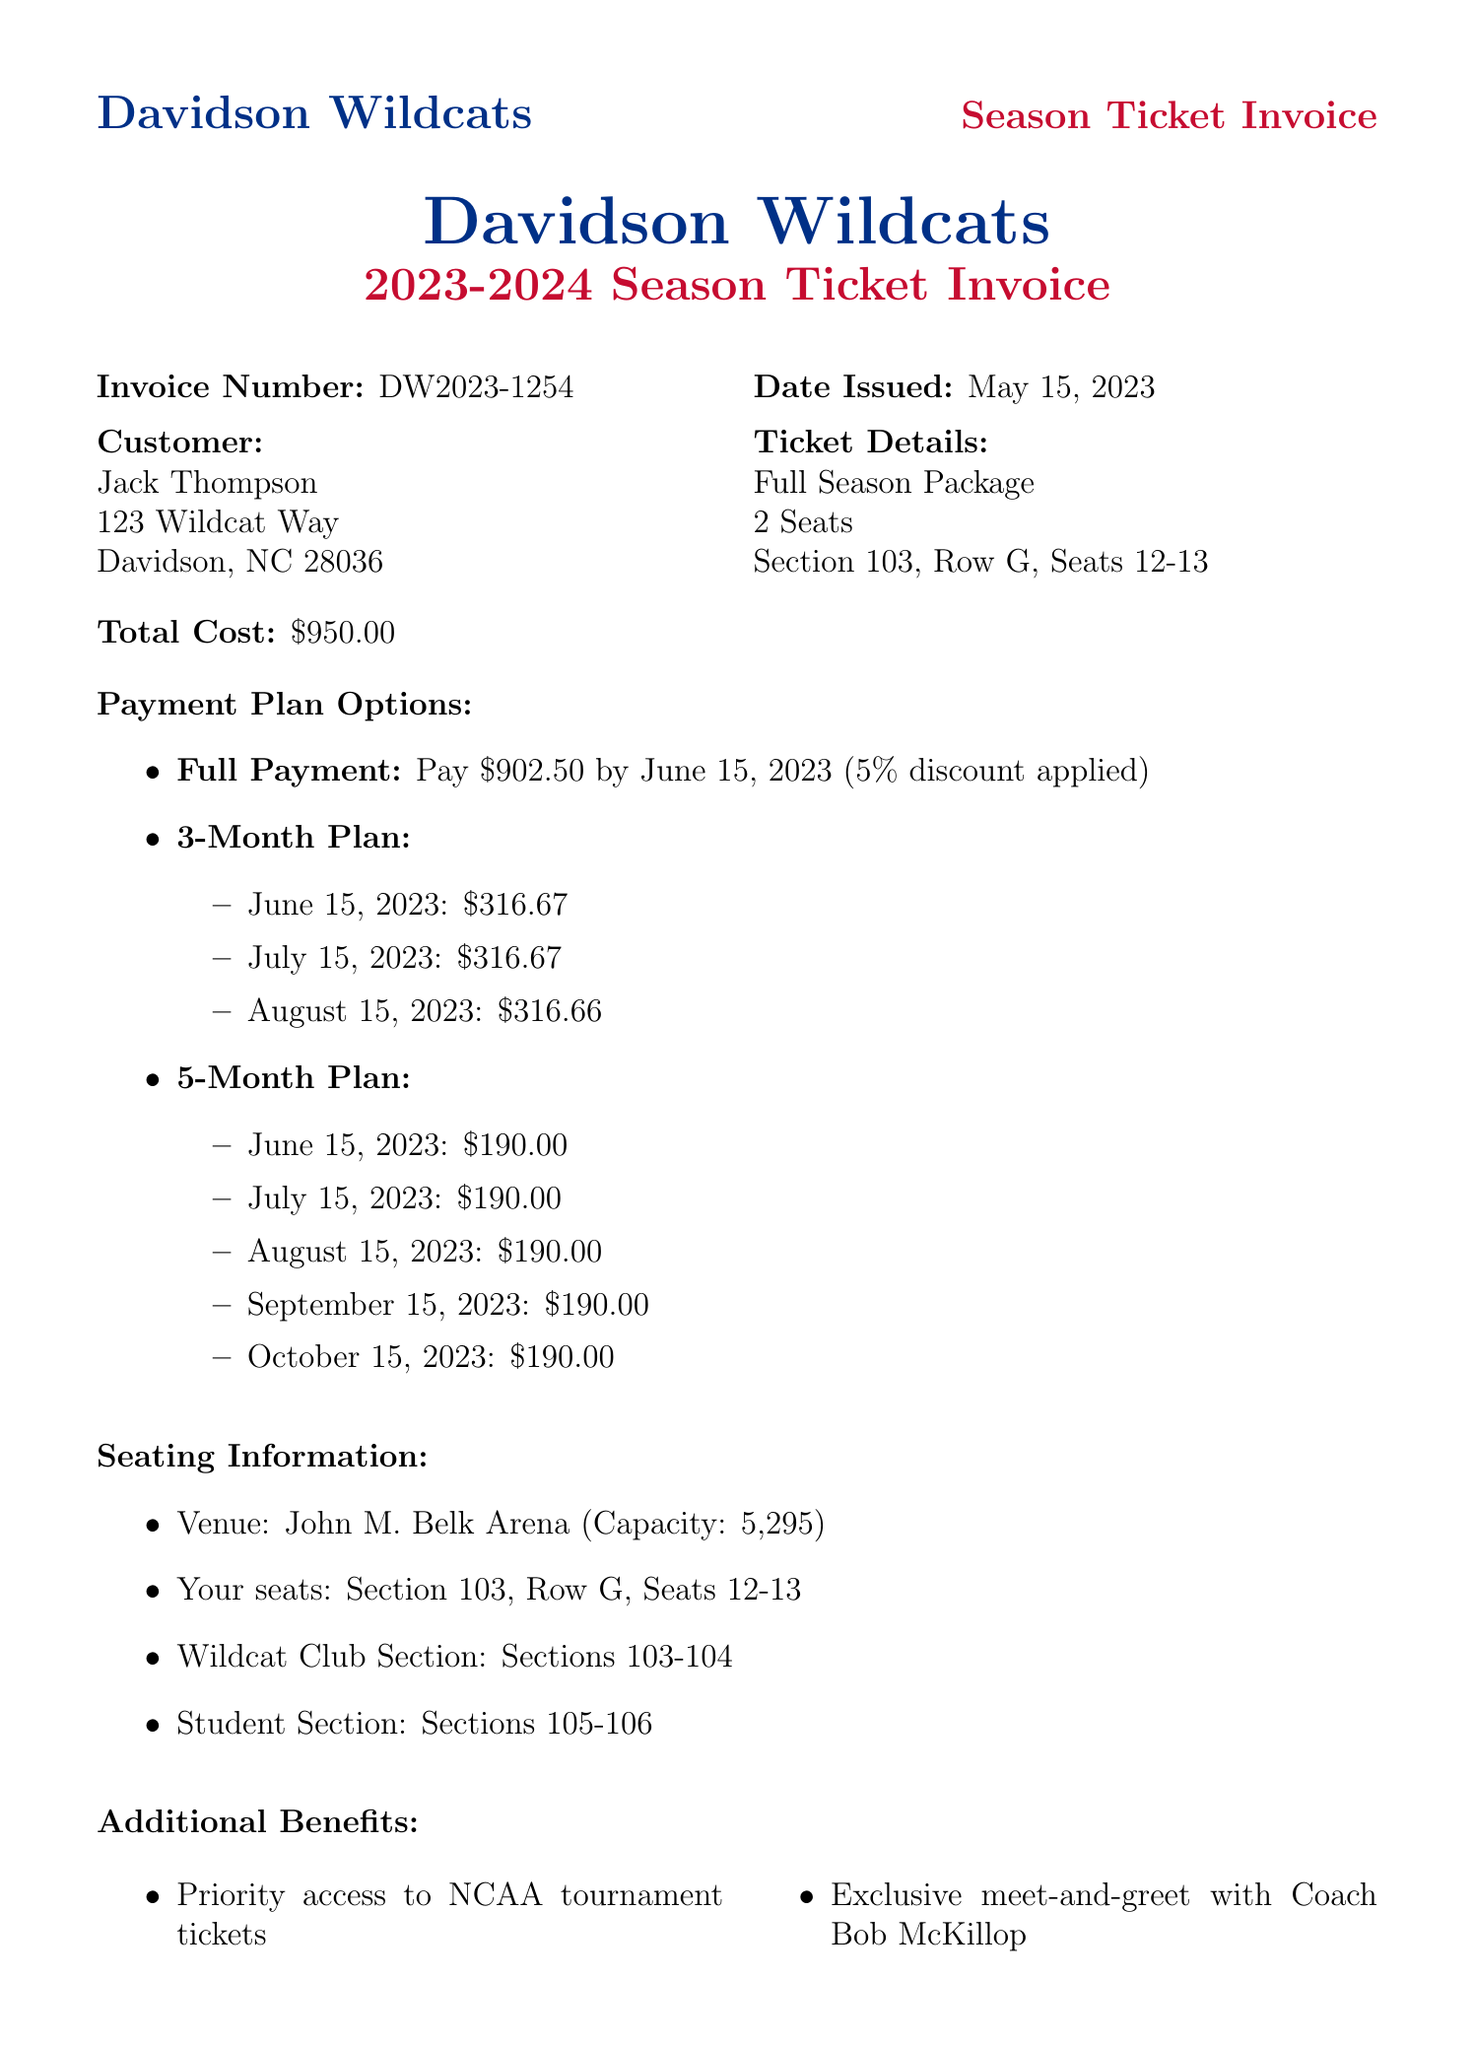What is the invoice number? The invoice number is listed at the top of the document as DW2023-1254.
Answer: DW2023-1254 When was the invoice issued? The date issued for the invoice appears in the document as May 15, 2023.
Answer: May 15, 2023 What is the total cost of the season tickets? The total cost is specified in the document as $950.00.
Answer: $950.00 Which section are the seats located in? The seat location is mentioned in the document as Section 103.
Answer: Section 103 How many payment plans are available? The document outlines three different payment plans for the customer.
Answer: 3 What is the discount offered for full payment? The document states that a 5% discount is applied for the full payment option.
Answer: 5% discount What notable game is against the Duke Blue Devils? The document lists the game against the Duke Blue Devils on November 10, 2023.
Answer: November 10, 2023 What is the capacity of the venue? The capacity of John M. Belk Arena is noted in the document as 5,295.
Answer: 5,295 Is there a discount on merchandise for ticket holders? The document mentions a 10% discount on official merchandise for ticket holders.
Answer: 10% discount 